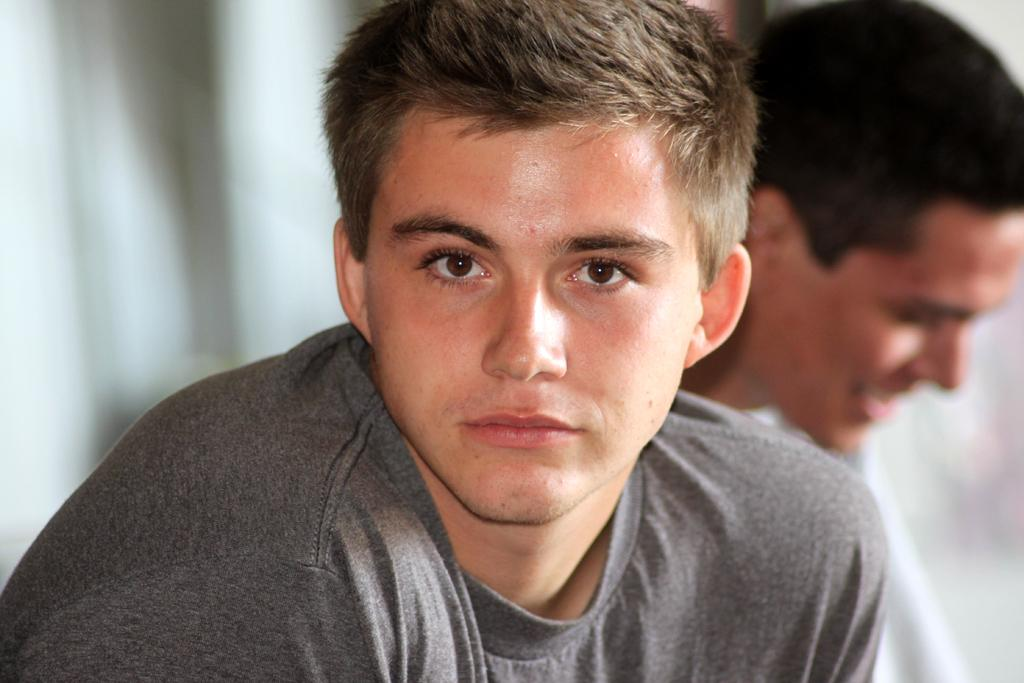What is the man in the image wearing? The man in the image is wearing a grey t-shirt. Where is the man located in the image? The man is in the front of the image. What can be seen in the center of the image? There is a person in the center of the image. What is the facial expression of the person in the center? The person in the center is smiling. How would you describe the background of the image? The background of the image is blurry. What are the boys arguing about in the image? There are no boys present in the image, and therefore no argument can be observed. 